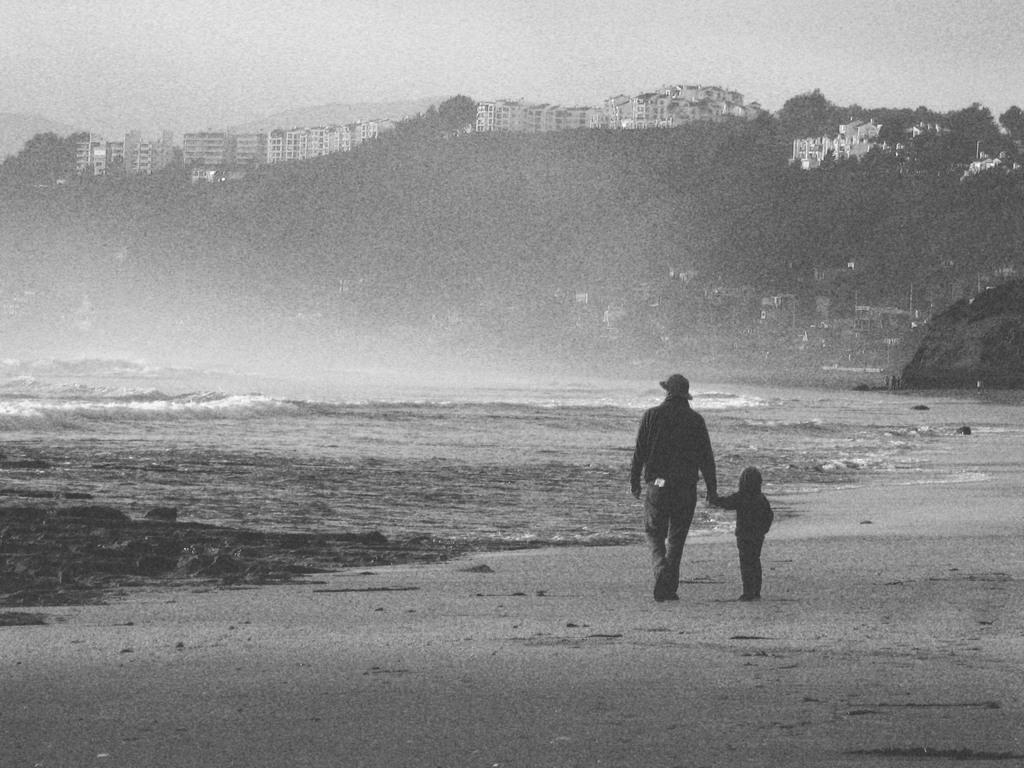Who is present in the image? There is a person in the image. What is the kid doing in the image? A kid is walking in the image. What type of natural environment can be seen in the image? There are trees in the image. What type of man-made structures can be seen in the image? There are buildings in the image. What part of the natural environment is visible in the image? The sky and the ocean are visible in the image. What type of farm animals can be seen in the image? There are no farm animals present in the image. What type of cork is used to seal the bottle in the image? There is no bottle or cork present in the image. 